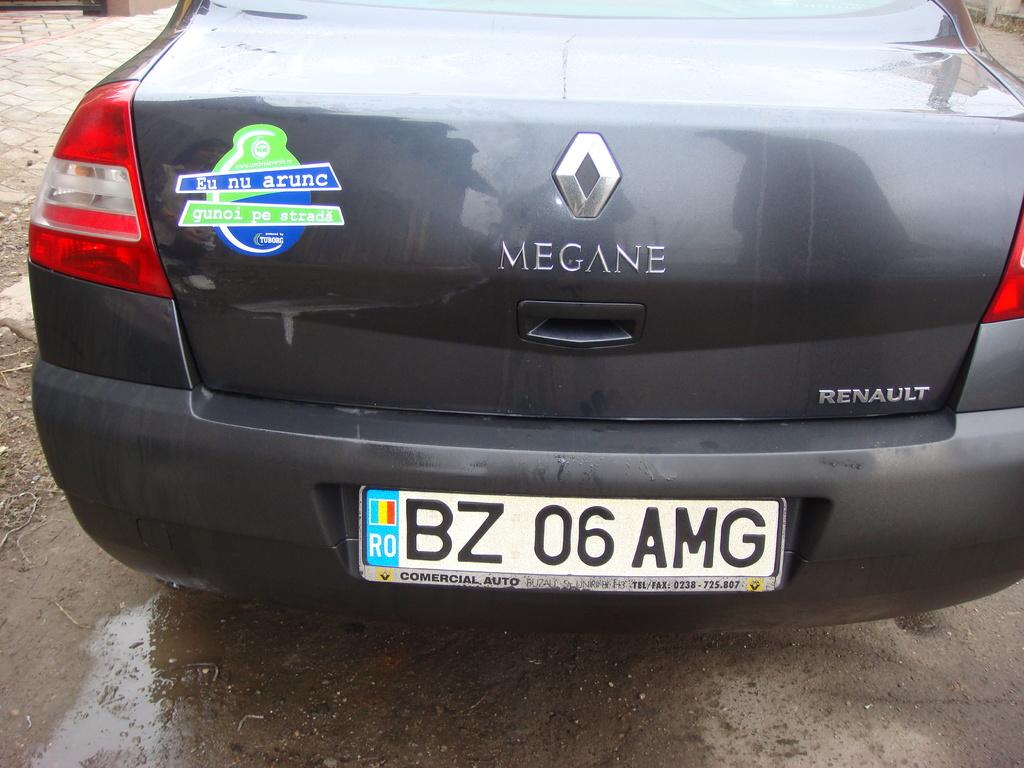<image>
Summarize the visual content of the image. A Renault brand Megane with a tag reading BZ 06  AMG. 